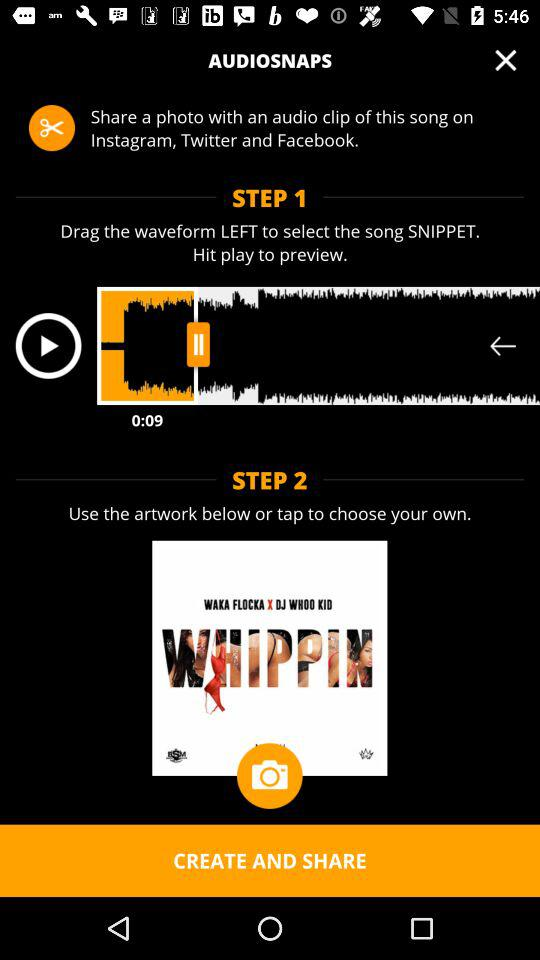How many steps are there?
When the provided information is insufficient, respond with <no answer>. <no answer> 